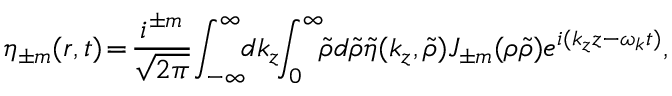Convert formula to latex. <formula><loc_0><loc_0><loc_500><loc_500>\eta _ { \pm m } ( r , t ) \, = \, \frac { i ^ { \pm m } } { \sqrt { 2 \pi } } \, \int _ { - \infty } ^ { \infty } \, d k _ { z } \, \int _ { 0 } ^ { \infty } \, \tilde { \rho } d \tilde { \rho } \tilde { \eta } ( k _ { z } , \tilde { \rho } ) J _ { \pm m } ( \rho \tilde { \rho } ) e ^ { i ( k _ { z } z - \omega _ { k } t ) } ,</formula> 